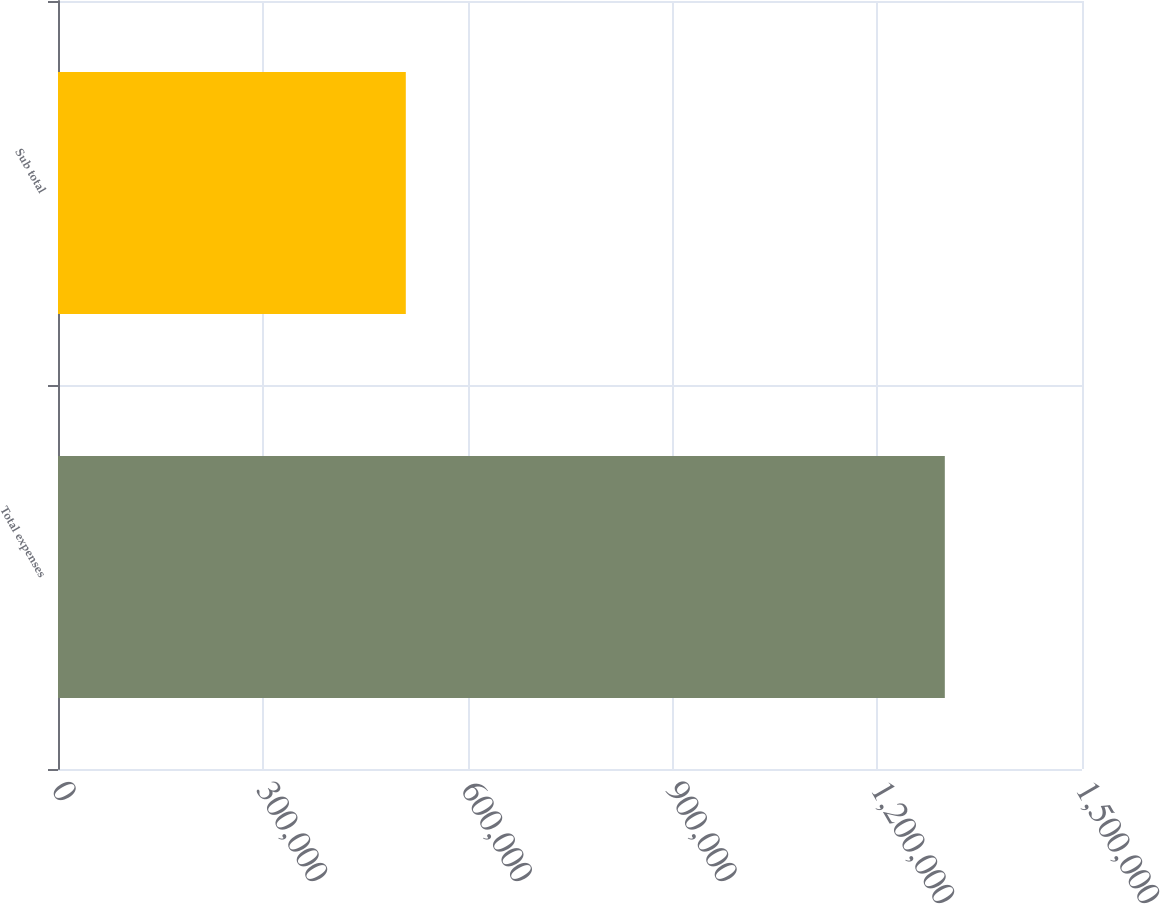Convert chart to OTSL. <chart><loc_0><loc_0><loc_500><loc_500><bar_chart><fcel>Total expenses<fcel>Sub total<nl><fcel>1.29905e+06<fcel>509476<nl></chart> 